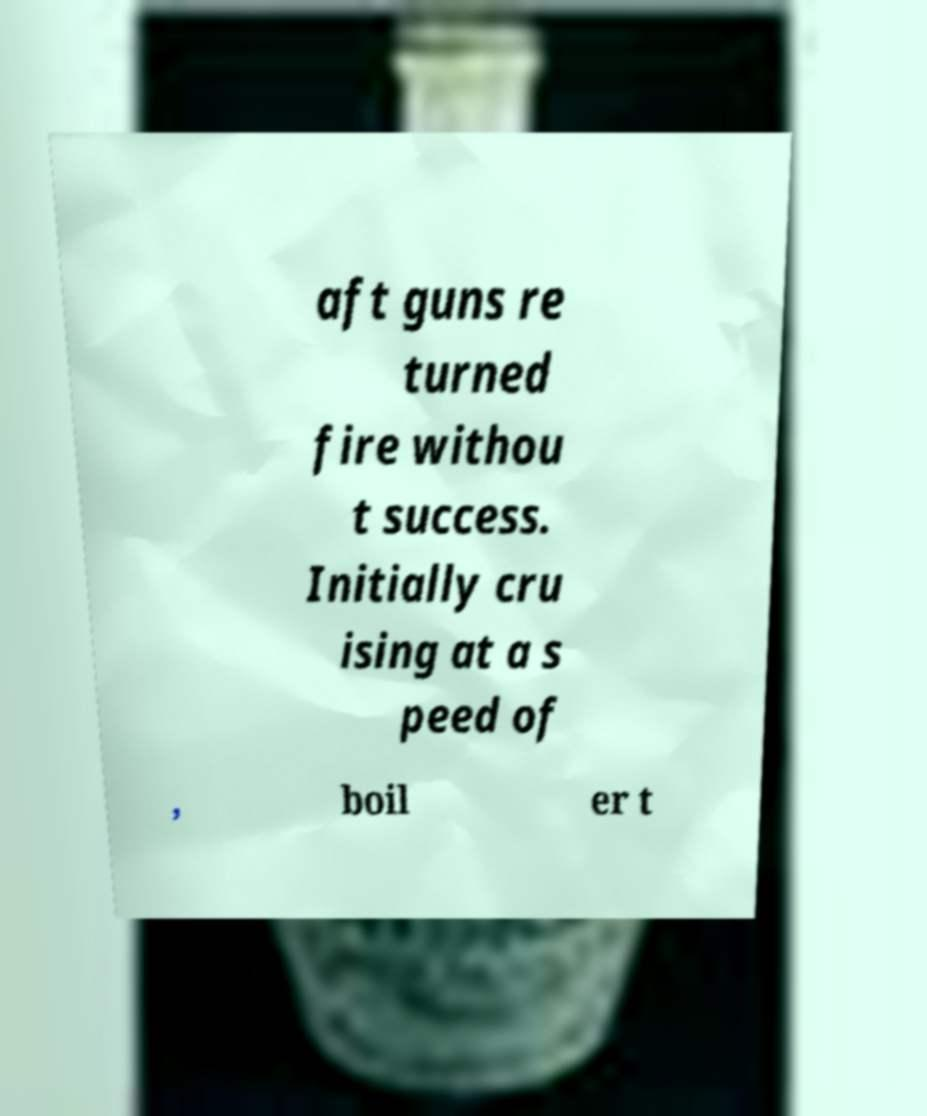For documentation purposes, I need the text within this image transcribed. Could you provide that? aft guns re turned fire withou t success. Initially cru ising at a s peed of , boil er t 